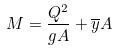Convert formula to latex. <formula><loc_0><loc_0><loc_500><loc_500>M = \frac { Q ^ { 2 } } { g A } + \overline { y } A</formula> 